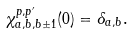<formula> <loc_0><loc_0><loc_500><loc_500>\chi ^ { p , p ^ { \prime } } _ { a , b , b \pm 1 } ( 0 ) = \delta _ { a , b } .</formula> 